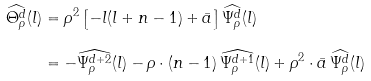Convert formula to latex. <formula><loc_0><loc_0><loc_500><loc_500>\widehat { \Theta _ { \rho } ^ { d } } ( l ) & = \rho ^ { 2 } \left [ - l ( l + n - 1 ) + \bar { a } \right ] \widehat { \Psi _ { \rho } ^ { d } } ( l ) \\ & = - \widehat { \Psi _ { \rho } ^ { d + 2 } } ( l ) - \rho \cdot ( n - 1 ) \, \widehat { \Psi _ { \rho } ^ { d + 1 } } ( l ) + \rho ^ { 2 } \cdot \bar { a } \, \widehat { \Psi _ { \rho } ^ { d } } ( l )</formula> 